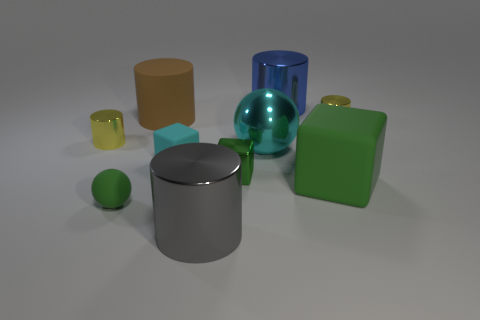There is a large object that is the same color as the small matte block; what is its material?
Your response must be concise. Metal. There is a blue cylinder; are there any large rubber objects on the right side of it?
Ensure brevity in your answer.  Yes. How many metal objects are small yellow cylinders or blue objects?
Your answer should be very brief. 3. There is a blue cylinder; how many big cubes are left of it?
Keep it short and to the point. 0. Are there any green matte objects of the same size as the cyan matte block?
Your answer should be very brief. Yes. Are there any large blocks that have the same color as the small shiny cube?
Your response must be concise. Yes. What number of tiny cubes have the same color as the rubber ball?
Give a very brief answer. 1. Is the color of the small metallic block the same as the rubber thing that is in front of the green rubber cube?
Your answer should be very brief. Yes. How many things are either large brown rubber cylinders or rubber objects to the left of the cyan sphere?
Your response must be concise. 3. What size is the green block on the left side of the matte cube that is right of the tiny green cube?
Your response must be concise. Small. 